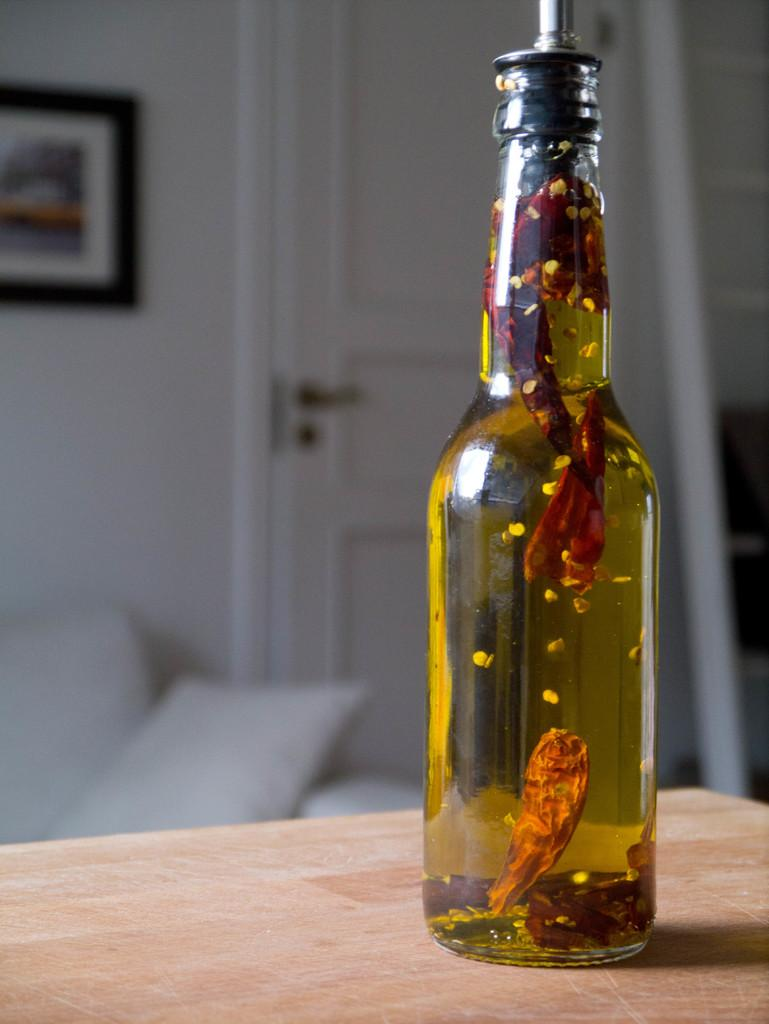What is in the bottle that is visible in the image? There is a bottle with liquid in the image. Where is the bottle located in the image? The bottle is on a table in the image. What can be seen in the background of the image? There is a sofa and a photo frame in the background of the image. What type of poison is in the bottle in the image? There is no poison present in the image; it is a bottle with liquid. How many cars can be seen in the image? There are no cars visible in the image. 